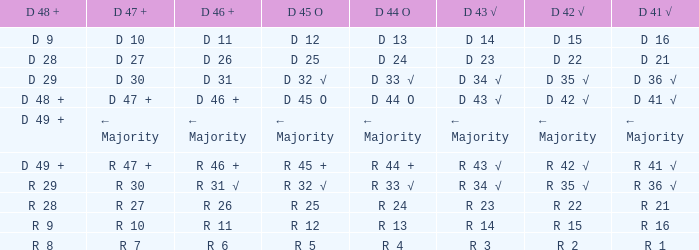What is the value of d 42 √ when d 45 o has a value of d 32 √? D 35 √. 